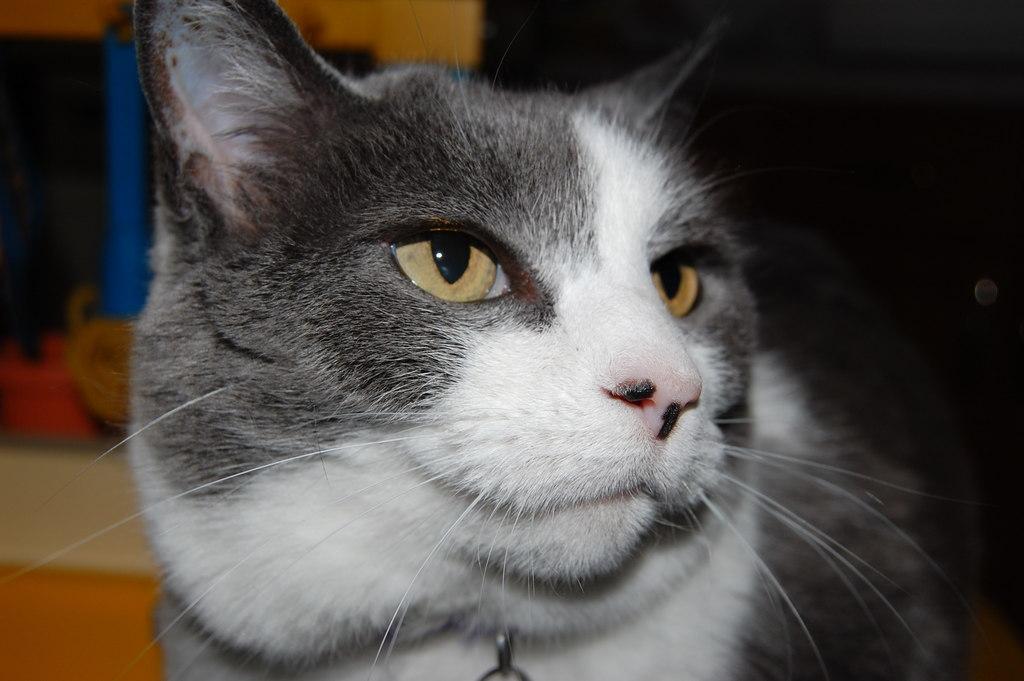Please provide a concise description of this image. In this image in the foreground there is one cat, and in the background there are some objects. 